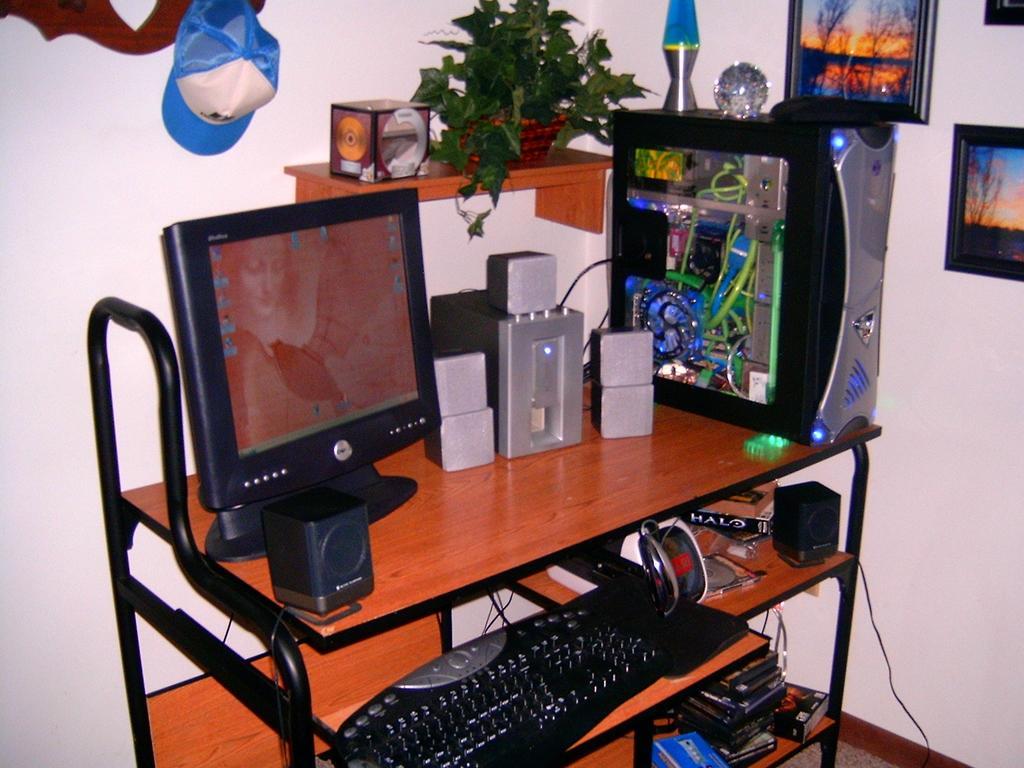Please provide a concise description of this image. If you look at the middle of an image there is a computer,keyboard,speakers, the computer table behind that there is a wall,cap 